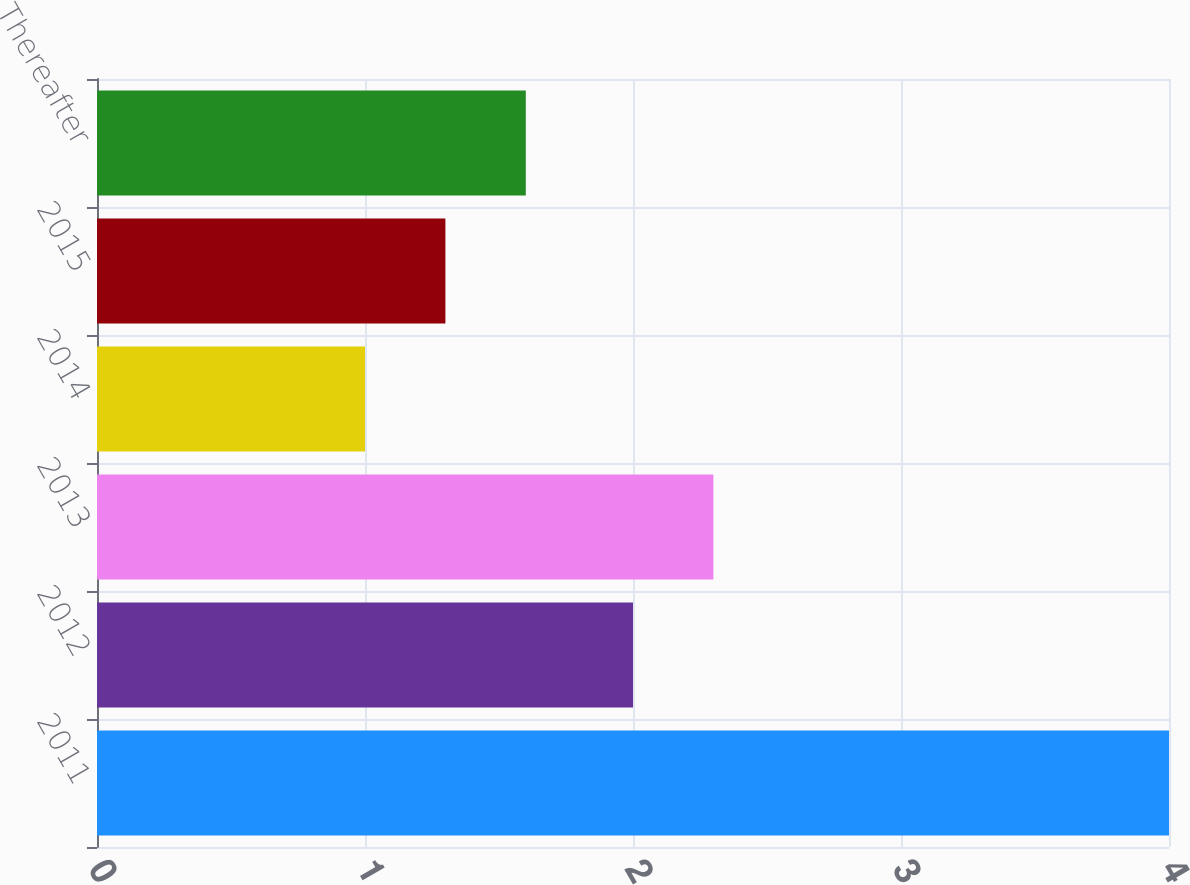<chart> <loc_0><loc_0><loc_500><loc_500><bar_chart><fcel>2011<fcel>2012<fcel>2013<fcel>2014<fcel>2015<fcel>Thereafter<nl><fcel>4<fcel>2<fcel>2.3<fcel>1<fcel>1.3<fcel>1.6<nl></chart> 